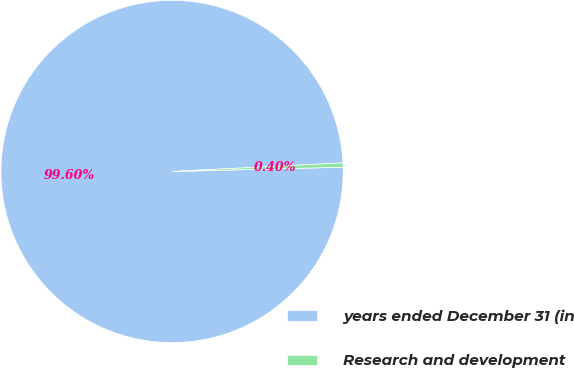Convert chart. <chart><loc_0><loc_0><loc_500><loc_500><pie_chart><fcel>years ended December 31 (in<fcel>Research and development<nl><fcel>99.6%<fcel>0.4%<nl></chart> 